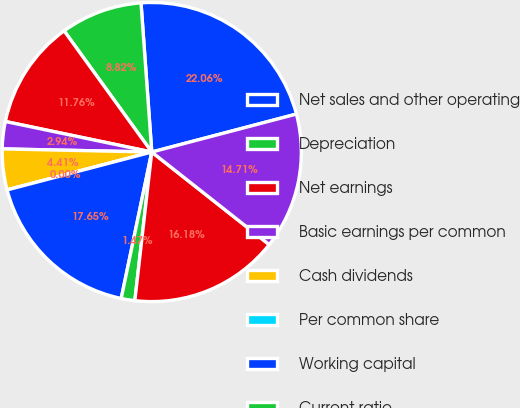Convert chart to OTSL. <chart><loc_0><loc_0><loc_500><loc_500><pie_chart><fcel>Net sales and other operating<fcel>Depreciation<fcel>Net earnings<fcel>Basic earnings per common<fcel>Cash dividends<fcel>Per common share<fcel>Working capital<fcel>Current ratio<fcel>Inventories<fcel>Net property plant and<nl><fcel>22.06%<fcel>8.82%<fcel>11.76%<fcel>2.94%<fcel>4.41%<fcel>0.0%<fcel>17.65%<fcel>1.47%<fcel>16.18%<fcel>14.71%<nl></chart> 